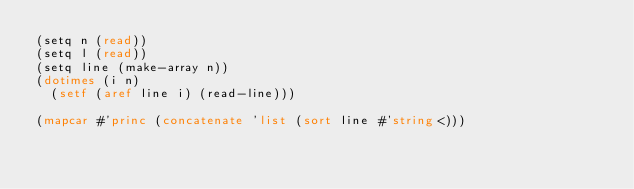Convert code to text. <code><loc_0><loc_0><loc_500><loc_500><_Lisp_>(setq n (read))
(setq l (read))
(setq line (make-array n))
(dotimes (i n)
  (setf (aref line i) (read-line)))

(mapcar #'princ (concatenate 'list (sort line #'string<)))
</code> 